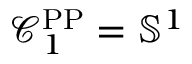Convert formula to latex. <formula><loc_0><loc_0><loc_500><loc_500>\mathcal { C } _ { 1 } ^ { P P } = \mathbb { S } ^ { 1 }</formula> 